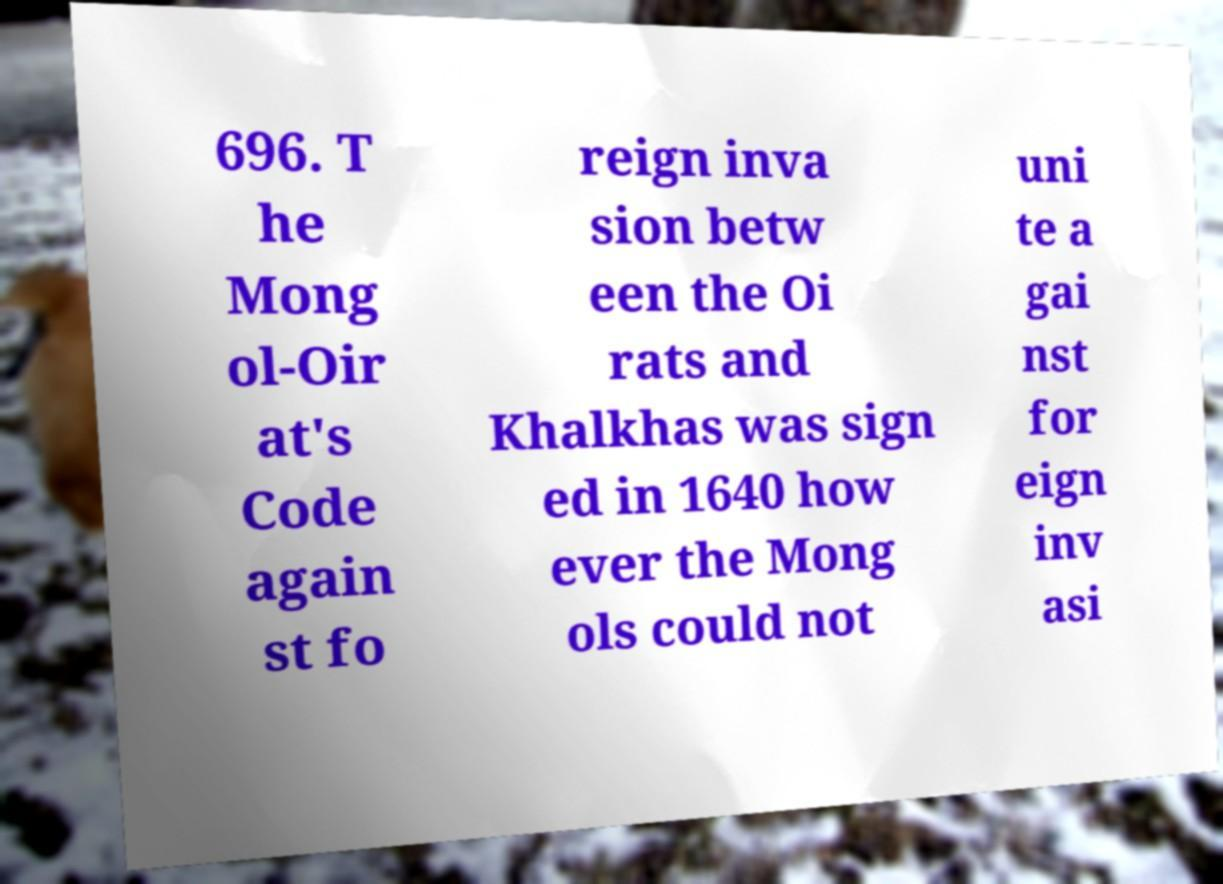I need the written content from this picture converted into text. Can you do that? 696. T he Mong ol-Oir at's Code again st fo reign inva sion betw een the Oi rats and Khalkhas was sign ed in 1640 how ever the Mong ols could not uni te a gai nst for eign inv asi 